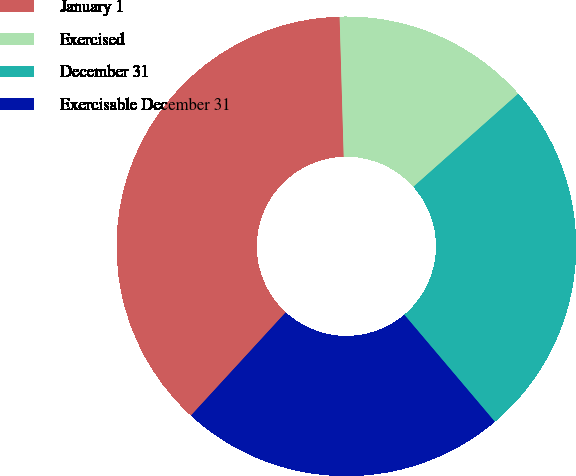<chart> <loc_0><loc_0><loc_500><loc_500><pie_chart><fcel>January 1<fcel>Exercised<fcel>December 31<fcel>Exercisable December 31<nl><fcel>37.71%<fcel>13.91%<fcel>25.38%<fcel>23.0%<nl></chart> 